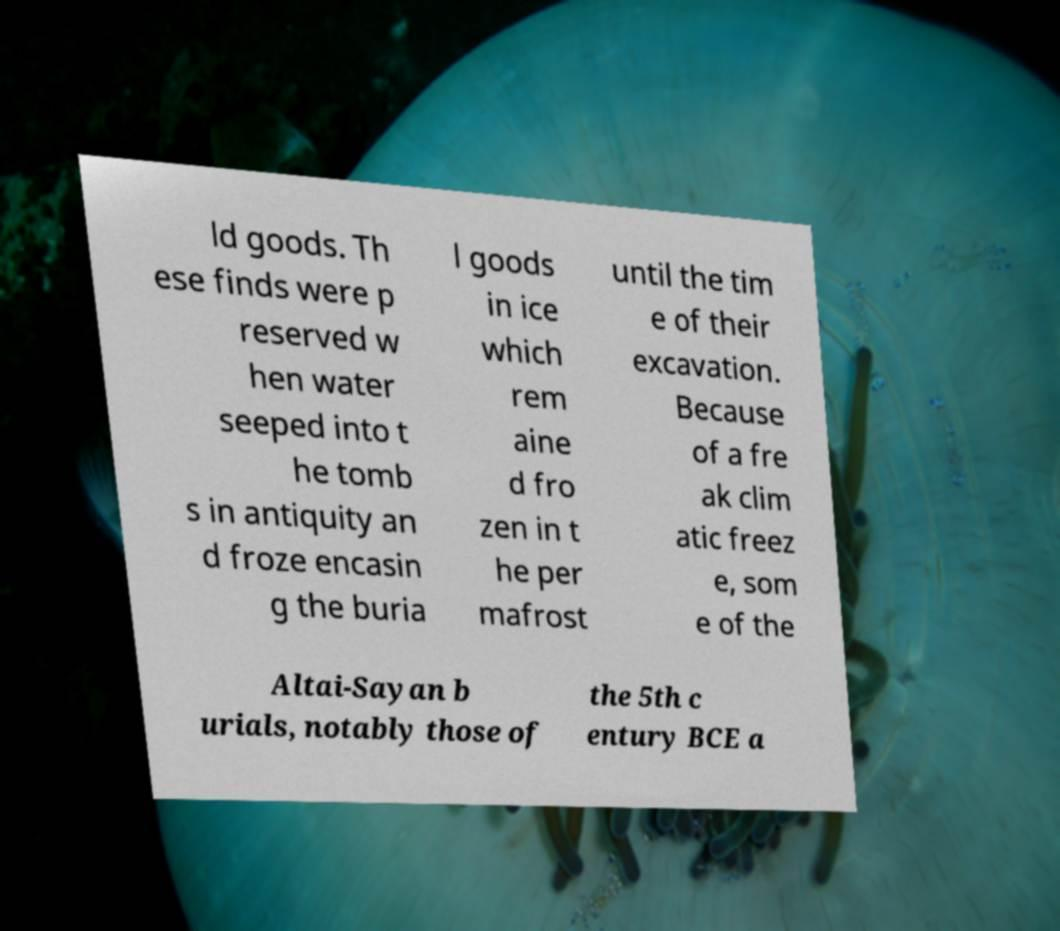Can you read and provide the text displayed in the image?This photo seems to have some interesting text. Can you extract and type it out for me? ld goods. Th ese finds were p reserved w hen water seeped into t he tomb s in antiquity an d froze encasin g the buria l goods in ice which rem aine d fro zen in t he per mafrost until the tim e of their excavation. Because of a fre ak clim atic freez e, som e of the Altai-Sayan b urials, notably those of the 5th c entury BCE a 